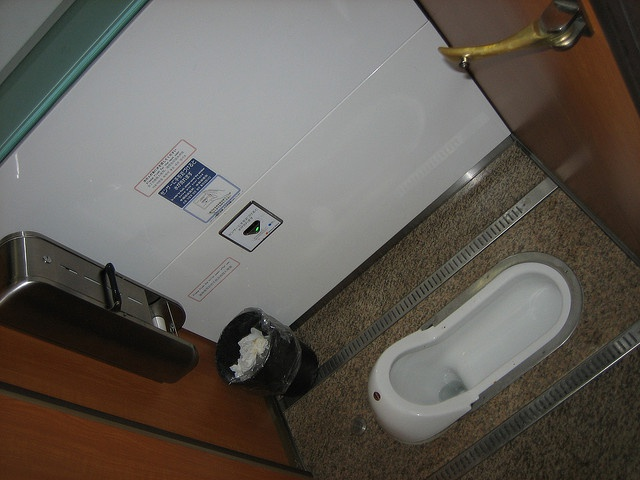Describe the objects in this image and their specific colors. I can see a toilet in gray tones in this image. 